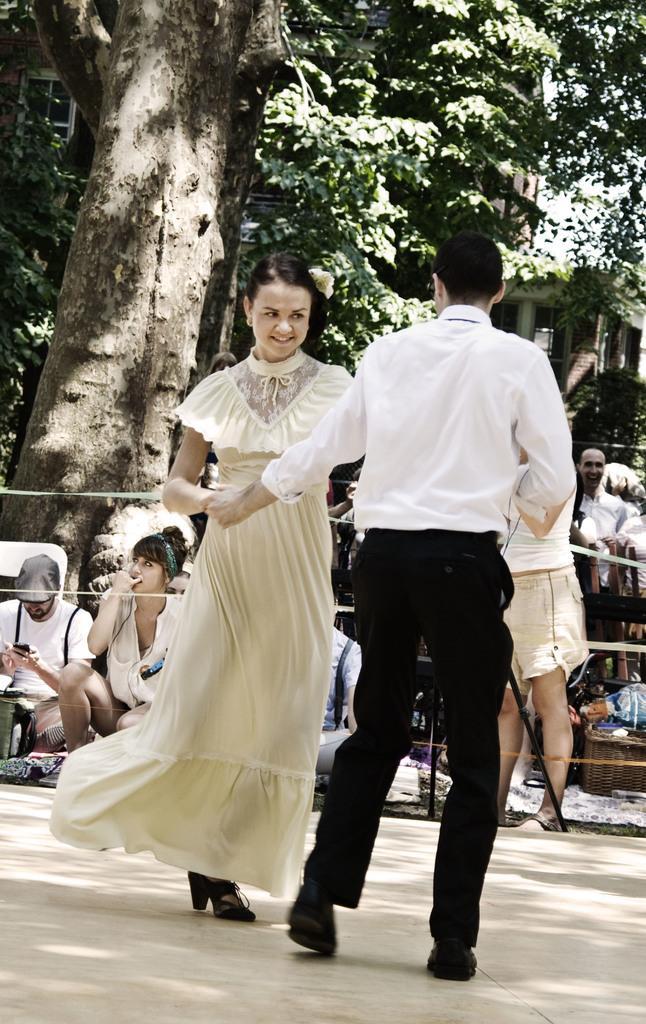How would you summarize this image in a sentence or two? This picture is clicked outside. In the foreground we can see the two persons seems to be dancing on the ground. In the background we can see the group of people and we can see the sky, buildings and trees. 